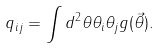Convert formula to latex. <formula><loc_0><loc_0><loc_500><loc_500>q _ { i j } = \int d ^ { 2 } \theta \theta _ { i } \theta _ { j } g ( \vec { \theta } ) .</formula> 